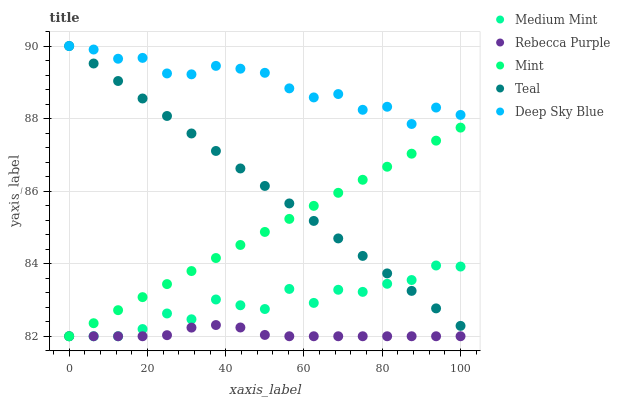Does Rebecca Purple have the minimum area under the curve?
Answer yes or no. Yes. Does Deep Sky Blue have the maximum area under the curve?
Answer yes or no. Yes. Does Mint have the minimum area under the curve?
Answer yes or no. No. Does Mint have the maximum area under the curve?
Answer yes or no. No. Is Mint the smoothest?
Answer yes or no. Yes. Is Medium Mint the roughest?
Answer yes or no. Yes. Is Deep Sky Blue the smoothest?
Answer yes or no. No. Is Deep Sky Blue the roughest?
Answer yes or no. No. Does Medium Mint have the lowest value?
Answer yes or no. Yes. Does Deep Sky Blue have the lowest value?
Answer yes or no. No. Does Teal have the highest value?
Answer yes or no. Yes. Does Mint have the highest value?
Answer yes or no. No. Is Mint less than Deep Sky Blue?
Answer yes or no. Yes. Is Teal greater than Rebecca Purple?
Answer yes or no. Yes. Does Teal intersect Deep Sky Blue?
Answer yes or no. Yes. Is Teal less than Deep Sky Blue?
Answer yes or no. No. Is Teal greater than Deep Sky Blue?
Answer yes or no. No. Does Mint intersect Deep Sky Blue?
Answer yes or no. No. 